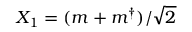Convert formula to latex. <formula><loc_0><loc_0><loc_500><loc_500>X _ { 1 } = ( m + m ^ { \dagger } ) / \sqrt { 2 }</formula> 